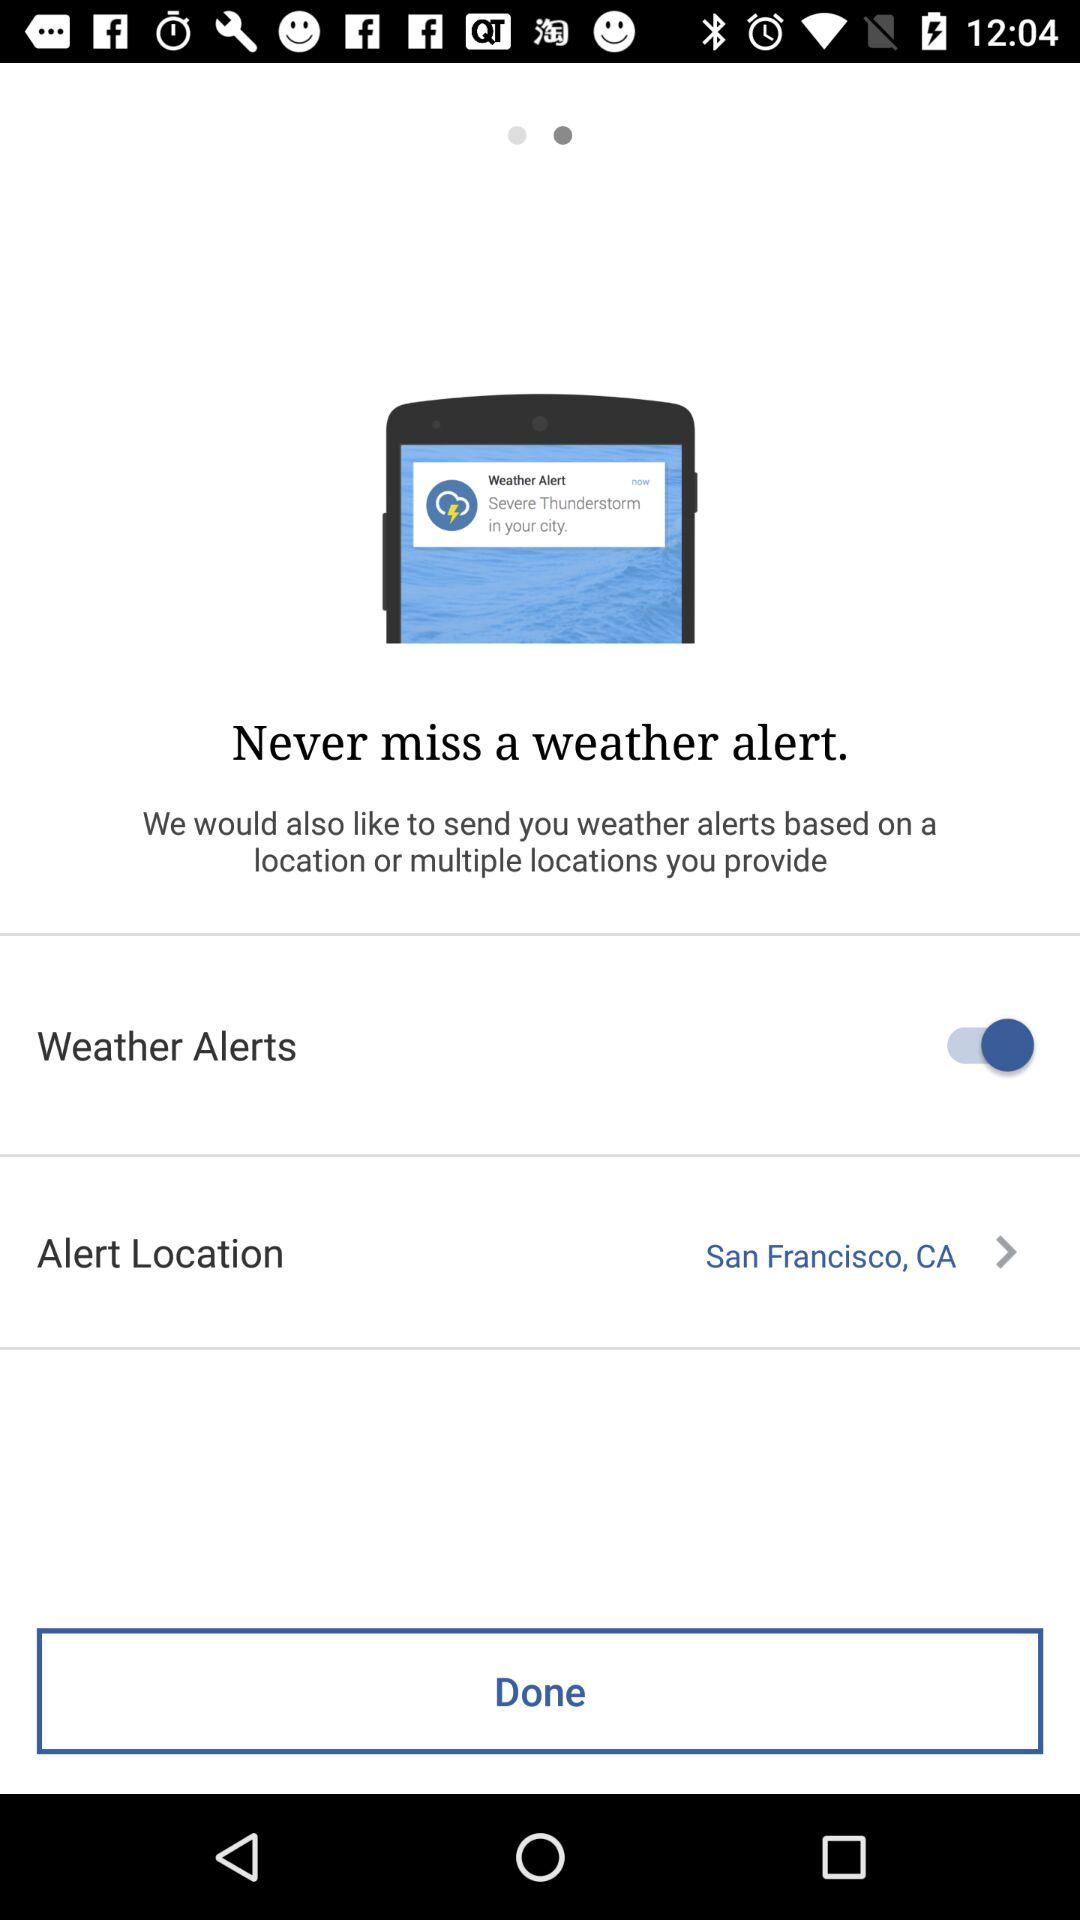What is the status of "Weather Alerts"? The status is "on". 